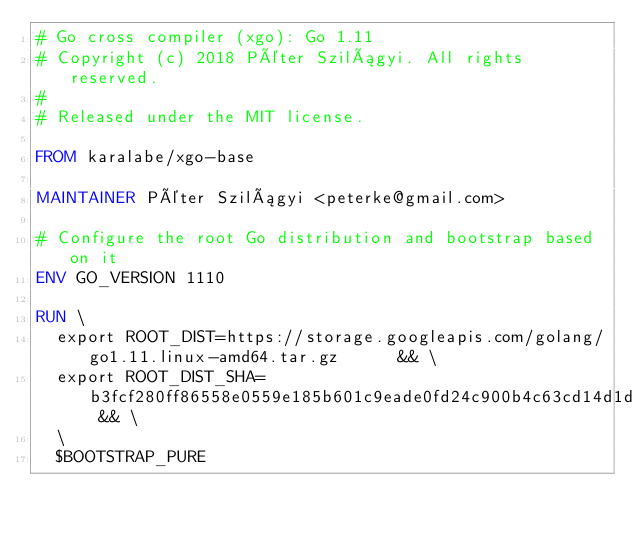<code> <loc_0><loc_0><loc_500><loc_500><_Dockerfile_># Go cross compiler (xgo): Go 1.11
# Copyright (c) 2018 Péter Szilágyi. All rights reserved.
#
# Released under the MIT license.

FROM karalabe/xgo-base

MAINTAINER Péter Szilágyi <peterke@gmail.com>

# Configure the root Go distribution and bootstrap based on it
ENV GO_VERSION 1110

RUN \
  export ROOT_DIST=https://storage.googleapis.com/golang/go1.11.linux-amd64.tar.gz      && \
  export ROOT_DIST_SHA=b3fcf280ff86558e0559e185b601c9eade0fd24c900b4c63cd14d1d38613e499 && \
  \
  $BOOTSTRAP_PURE
</code> 